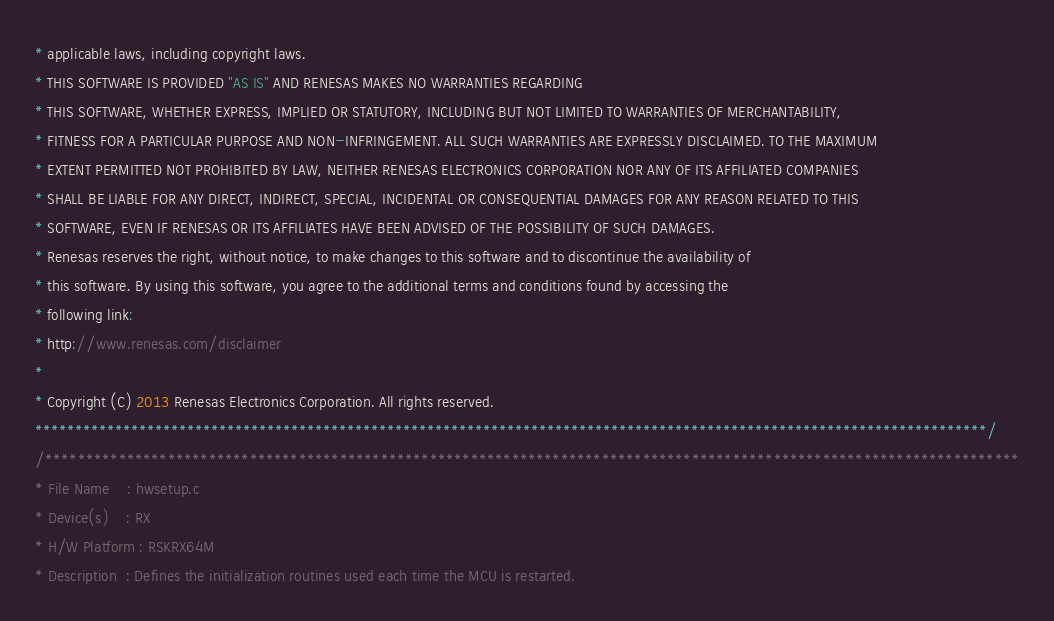Convert code to text. <code><loc_0><loc_0><loc_500><loc_500><_C_>* applicable laws, including copyright laws. 
* THIS SOFTWARE IS PROVIDED "AS IS" AND RENESAS MAKES NO WARRANTIES REGARDING
* THIS SOFTWARE, WHETHER EXPRESS, IMPLIED OR STATUTORY, INCLUDING BUT NOT LIMITED TO WARRANTIES OF MERCHANTABILITY, 
* FITNESS FOR A PARTICULAR PURPOSE AND NON-INFRINGEMENT. ALL SUCH WARRANTIES ARE EXPRESSLY DISCLAIMED. TO THE MAXIMUM 
* EXTENT PERMITTED NOT PROHIBITED BY LAW, NEITHER RENESAS ELECTRONICS CORPORATION NOR ANY OF ITS AFFILIATED COMPANIES 
* SHALL BE LIABLE FOR ANY DIRECT, INDIRECT, SPECIAL, INCIDENTAL OR CONSEQUENTIAL DAMAGES FOR ANY REASON RELATED TO THIS 
* SOFTWARE, EVEN IF RENESAS OR ITS AFFILIATES HAVE BEEN ADVISED OF THE POSSIBILITY OF SUCH DAMAGES.
* Renesas reserves the right, without notice, to make changes to this software and to discontinue the availability of 
* this software. By using this software, you agree to the additional terms and conditions found by accessing the 
* following link:
* http://www.renesas.com/disclaimer 
*
* Copyright (C) 2013 Renesas Electronics Corporation. All rights reserved.    
***********************************************************************************************************************/
/***********************************************************************************************************************
* File Name    : hwsetup.c
* Device(s)    : RX
* H/W Platform : RSKRX64M
* Description  : Defines the initialization routines used each time the MCU is restarted.</code> 